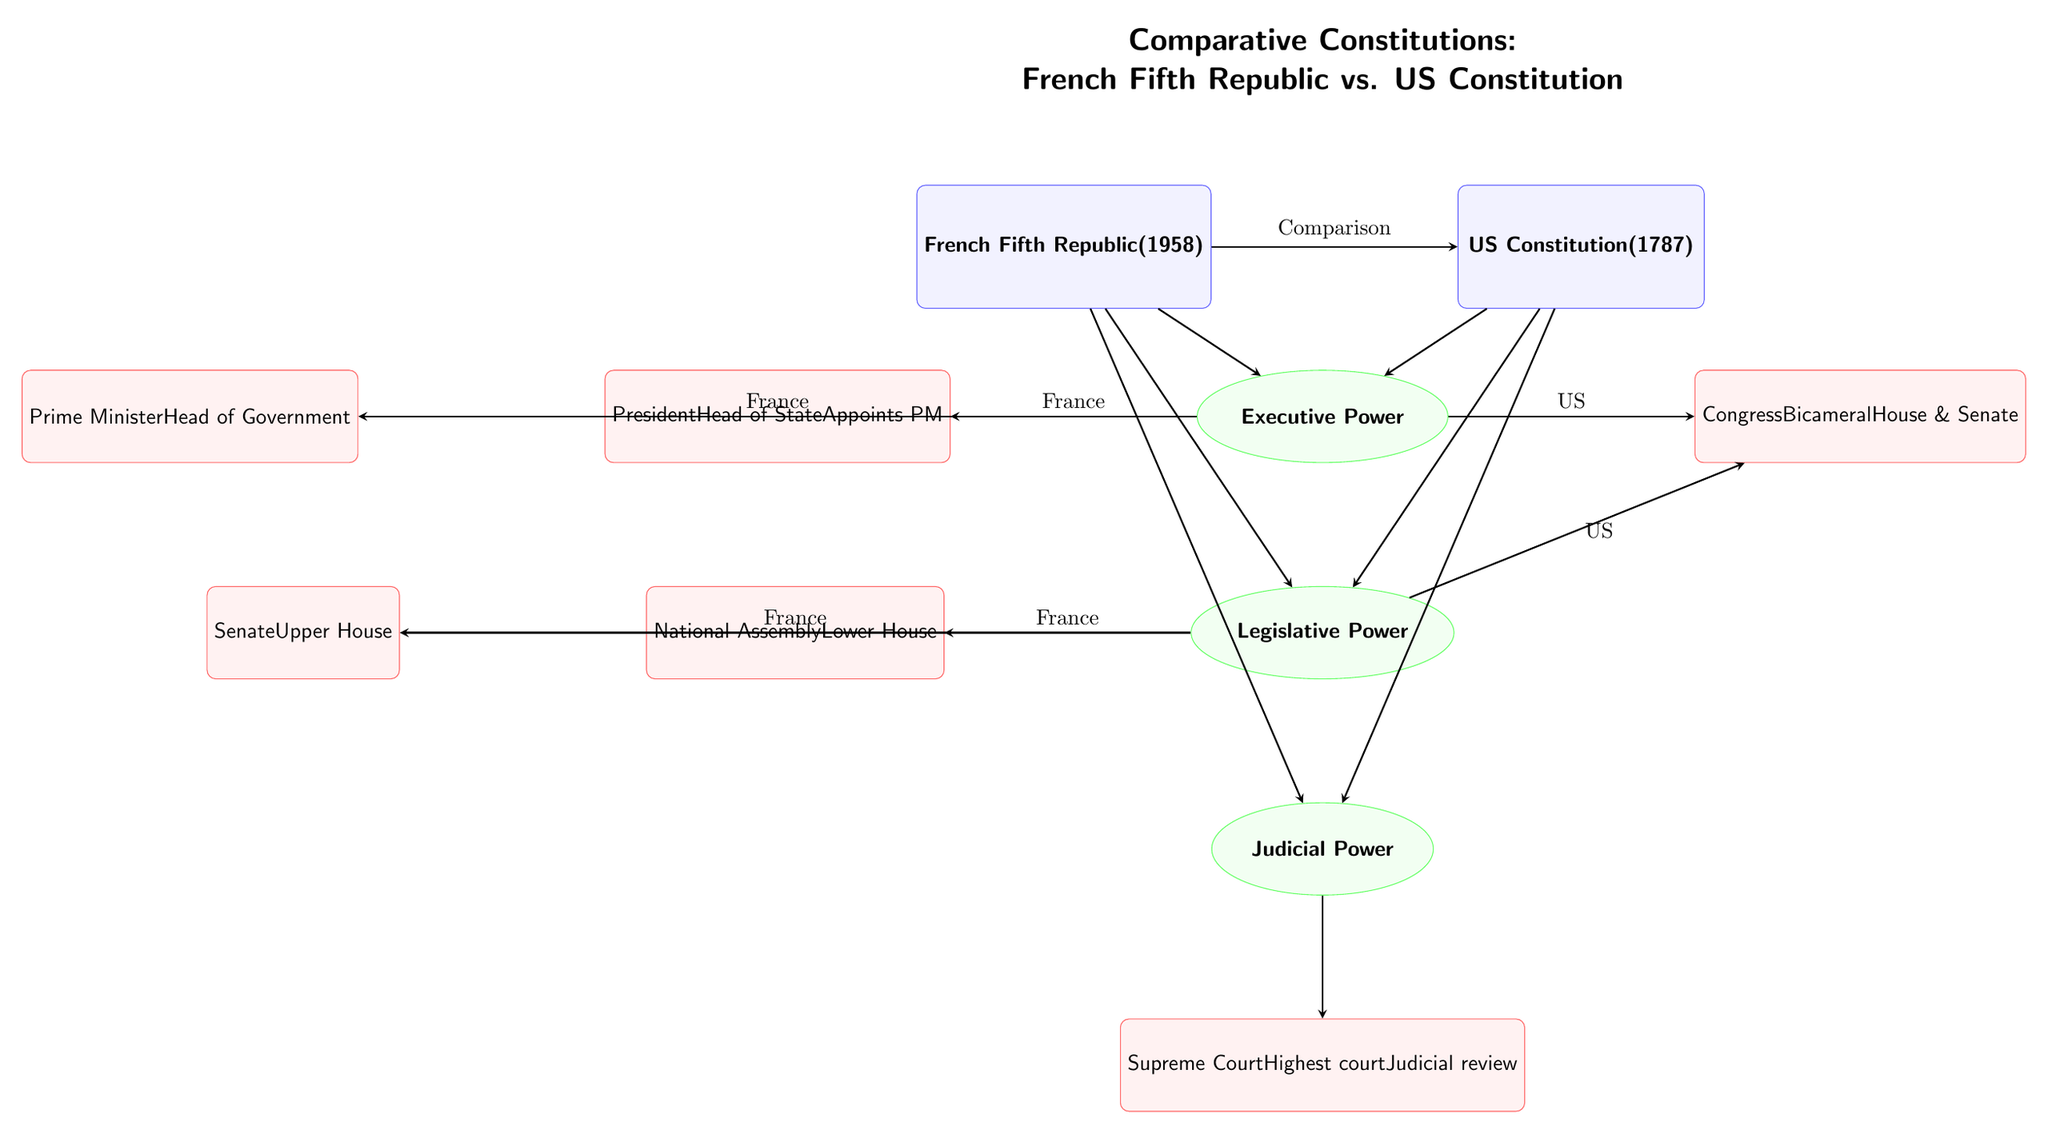What year was the French Fifth Republic established? The diagram states that the French Fifth Republic was established in 1958. This information can be found directly in the node representing the French constitution.
Answer: 1958 What is the name of the upper house in the French legislative system? The diagram indicates that the upper house is called the Senate, which is shown in the attribute node connected to the Legislative Power feature under the French side.
Answer: Senate How many branches of government are shown in the diagram for each constitution? The diagram displays three main branches of government: Executive Power, Legislative Power, and Judicial Power. Both France and the USA have these three branches, as indicated by the arrangement of the feature nodes below each country node.
Answer: 3 Which branch of government in the US is bicameral? The diagram shows that the Legislative Power of the US includes Congress, which is mentioned as bicameral, meaning it consists of two houses: the House and the Senate, directly written in the attribute node linked under the US side.
Answer: Congress What is the role of the President in the French system? According to the diagram, the President serves as the Head of State and appoints the Prime Minister, which is highlighted in the attribute nodes under the Executive Power feature specific to France.
Answer: Head of State Which country has a Prime Minister and a President? The diagram shows that France has both a Prime Minister and a President, indicated by the separate attribute nodes under the Executive Power feature, while the US only has a President. This means that France is the answer.
Answer: France What type of judicial system is represented in the diagram for both countries? The diagram indicates a Supreme Court for both the French and US systems under the Judicial Power feature, which means that both systems have a highest court. However, only the US system's judicial review is specifically mentioned.
Answer: Supreme Court What connects the frameworks of the French Fifth Republic and the US Constitution in the diagram? The main connection is the comparison edge that links both country nodes, illustrating that the diagram is focused on a comparative analysis between these two constitutions.
Answer: Comparison 